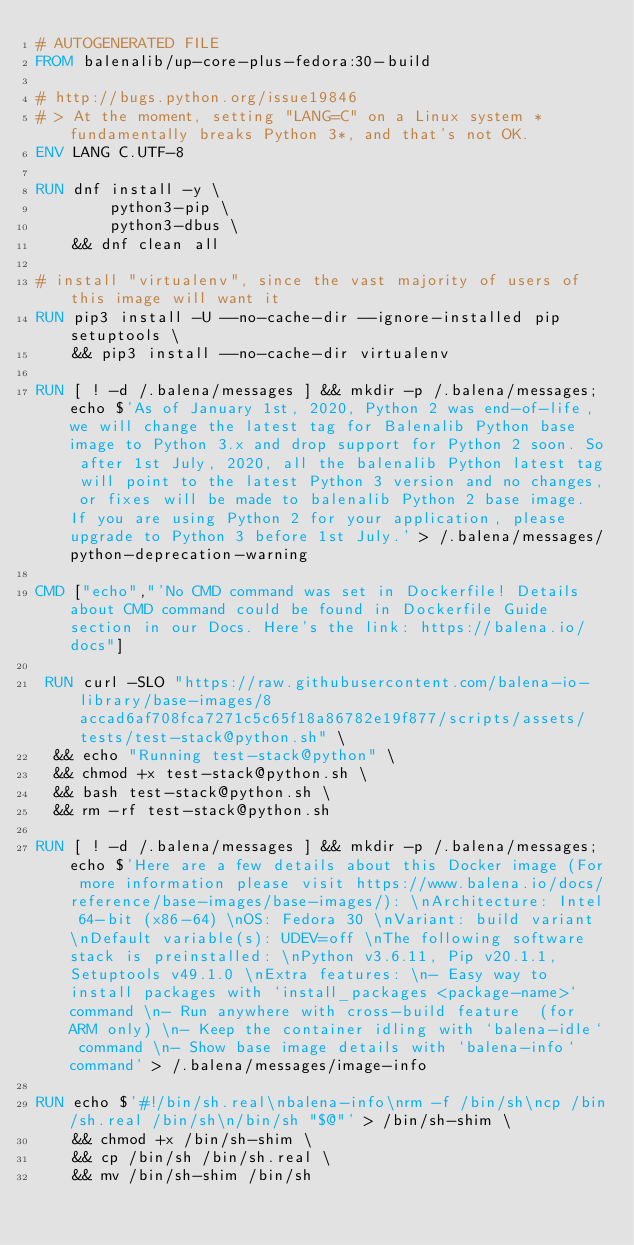<code> <loc_0><loc_0><loc_500><loc_500><_Dockerfile_># AUTOGENERATED FILE
FROM balenalib/up-core-plus-fedora:30-build

# http://bugs.python.org/issue19846
# > At the moment, setting "LANG=C" on a Linux system *fundamentally breaks Python 3*, and that's not OK.
ENV LANG C.UTF-8

RUN dnf install -y \
		python3-pip \
		python3-dbus \
	&& dnf clean all

# install "virtualenv", since the vast majority of users of this image will want it
RUN pip3 install -U --no-cache-dir --ignore-installed pip setuptools \
	&& pip3 install --no-cache-dir virtualenv

RUN [ ! -d /.balena/messages ] && mkdir -p /.balena/messages; echo $'As of January 1st, 2020, Python 2 was end-of-life, we will change the latest tag for Balenalib Python base image to Python 3.x and drop support for Python 2 soon. So after 1st July, 2020, all the balenalib Python latest tag will point to the latest Python 3 version and no changes, or fixes will be made to balenalib Python 2 base image. If you are using Python 2 for your application, please upgrade to Python 3 before 1st July.' > /.balena/messages/python-deprecation-warning

CMD ["echo","'No CMD command was set in Dockerfile! Details about CMD command could be found in Dockerfile Guide section in our Docs. Here's the link: https://balena.io/docs"]

 RUN curl -SLO "https://raw.githubusercontent.com/balena-io-library/base-images/8accad6af708fca7271c5c65f18a86782e19f877/scripts/assets/tests/test-stack@python.sh" \
  && echo "Running test-stack@python" \
  && chmod +x test-stack@python.sh \
  && bash test-stack@python.sh \
  && rm -rf test-stack@python.sh 

RUN [ ! -d /.balena/messages ] && mkdir -p /.balena/messages; echo $'Here are a few details about this Docker image (For more information please visit https://www.balena.io/docs/reference/base-images/base-images/): \nArchitecture: Intel 64-bit (x86-64) \nOS: Fedora 30 \nVariant: build variant \nDefault variable(s): UDEV=off \nThe following software stack is preinstalled: \nPython v3.6.11, Pip v20.1.1, Setuptools v49.1.0 \nExtra features: \n- Easy way to install packages with `install_packages <package-name>` command \n- Run anywhere with cross-build feature  (for ARM only) \n- Keep the container idling with `balena-idle` command \n- Show base image details with `balena-info` command' > /.balena/messages/image-info

RUN echo $'#!/bin/sh.real\nbalena-info\nrm -f /bin/sh\ncp /bin/sh.real /bin/sh\n/bin/sh "$@"' > /bin/sh-shim \
	&& chmod +x /bin/sh-shim \
	&& cp /bin/sh /bin/sh.real \
	&& mv /bin/sh-shim /bin/sh</code> 